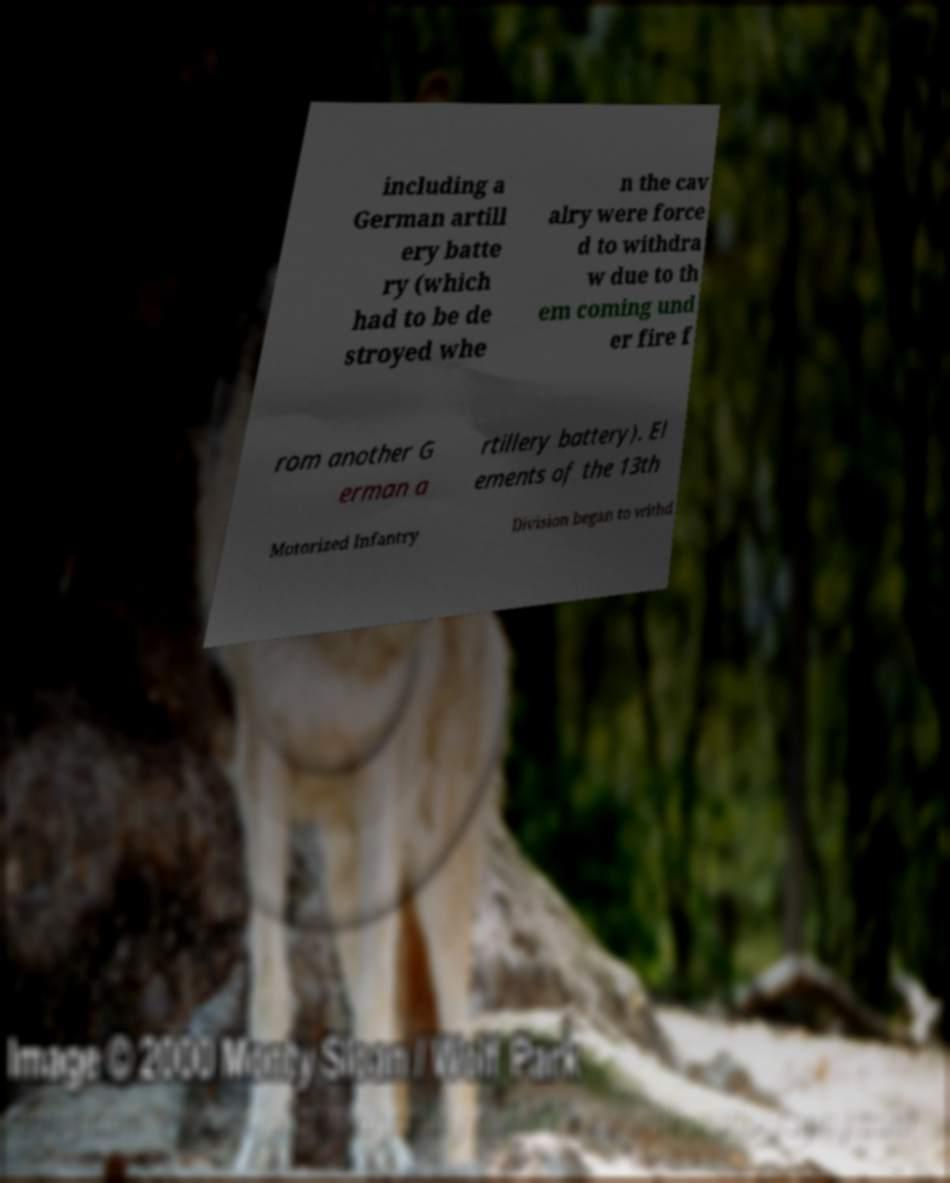Please identify and transcribe the text found in this image. including a German artill ery batte ry (which had to be de stroyed whe n the cav alry were force d to withdra w due to th em coming und er fire f rom another G erman a rtillery battery). El ements of the 13th Motorized Infantry Division began to withd 